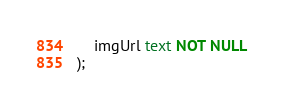<code> <loc_0><loc_0><loc_500><loc_500><_SQL_>    imgUrl text NOT NULL
);</code> 